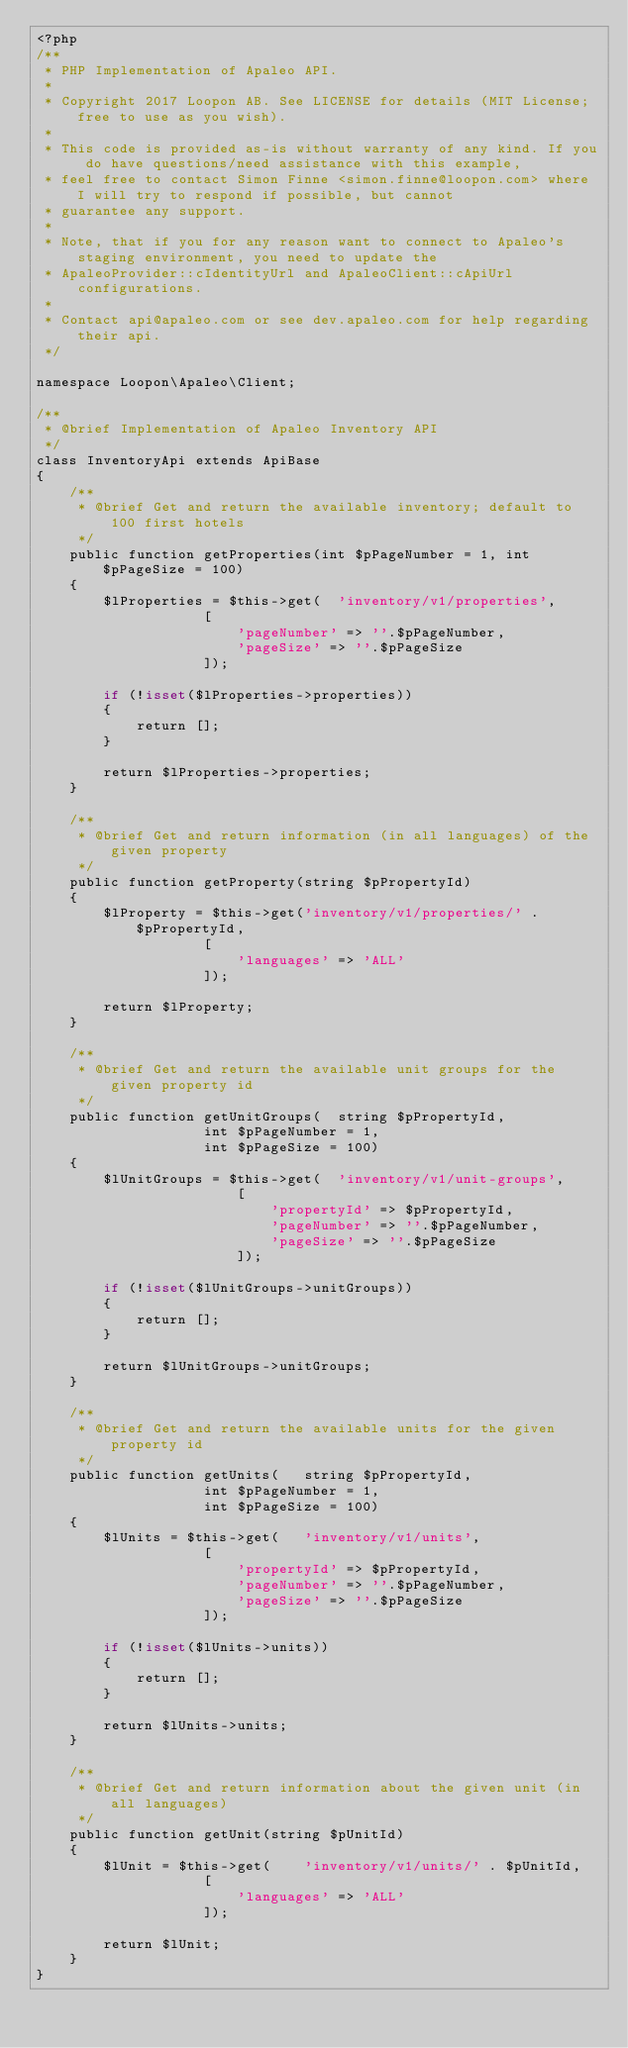Convert code to text. <code><loc_0><loc_0><loc_500><loc_500><_PHP_><?php
/**
 * PHP Implementation of Apaleo API.
 *
 * Copyright 2017 Loopon AB. See LICENSE for details (MIT License; free to use as you wish).
 *
 * This code is provided as-is without warranty of any kind. If you do have questions/need assistance with this example,
 * feel free to contact Simon Finne <simon.finne@loopon.com> where I will try to respond if possible, but cannot
 * guarantee any support.
 *
 * Note, that if you for any reason want to connect to Apaleo's staging environment, you need to update the
 * ApaleoProvider::cIdentityUrl and ApaleoClient::cApiUrl configurations.
 *
 * Contact api@apaleo.com or see dev.apaleo.com for help regarding their api.
 */

namespace Loopon\Apaleo\Client;

/**
 * @brief Implementation of Apaleo Inventory API
 */
class InventoryApi extends ApiBase
{
	/**
	 * @brief Get and return the available inventory; default to 100 first hotels
	 */
	public function getProperties(int $pPageNumber = 1, int $pPageSize = 100)
	{
		$lProperties = $this->get(	'inventory/v1/properties',
					[
						'pageNumber' => ''.$pPageNumber,
						'pageSize' => ''.$pPageSize
					]);

		if (!isset($lProperties->properties))
		{
			return [];
		}

		return $lProperties->properties;
	}

	/**
	 * @brief Get and return information (in all languages) of the given property
	 */
	public function getProperty(string $pPropertyId)
	{
		$lProperty = $this->get('inventory/v1/properties/' . $pPropertyId,
					[
						'languages' => 'ALL'
					]);

		return $lProperty;
	}

	/**
	 * @brief Get and return the available unit groups for the given property id
	 */
	public function getUnitGroups(	string $pPropertyId,
					int $pPageNumber = 1,
					int $pPageSize = 100)
	{
		$lUnitGroups = $this->get(	'inventory/v1/unit-groups',
						[
							'propertyId' => $pPropertyId,
							'pageNumber' => ''.$pPageNumber,
							'pageSize' => ''.$pPageSize
						]);

		if (!isset($lUnitGroups->unitGroups))
		{
			return [];
		}

		return $lUnitGroups->unitGroups;
	}

	/**
	 * @brief Get and return the available units for the given property id
	 */
	public function getUnits(	string $pPropertyId,
					int $pPageNumber = 1,
					int $pPageSize = 100)
	{
		$lUnits = $this->get(	'inventory/v1/units',
					[
						'propertyId' => $pPropertyId,
						'pageNumber' => ''.$pPageNumber,
						'pageSize' => ''.$pPageSize
					]);

		if (!isset($lUnits->units))
		{
			return [];
		}

		return $lUnits->units;
	}

	/**
	 * @brief Get and return information about the given unit (in all languages)
	 */
	public function getUnit(string $pUnitId)
	{
		$lUnit = $this->get(	'inventory/v1/units/' . $pUnitId,
					[
						'languages' => 'ALL'
					]);

		return $lUnit;
	}
}
</code> 